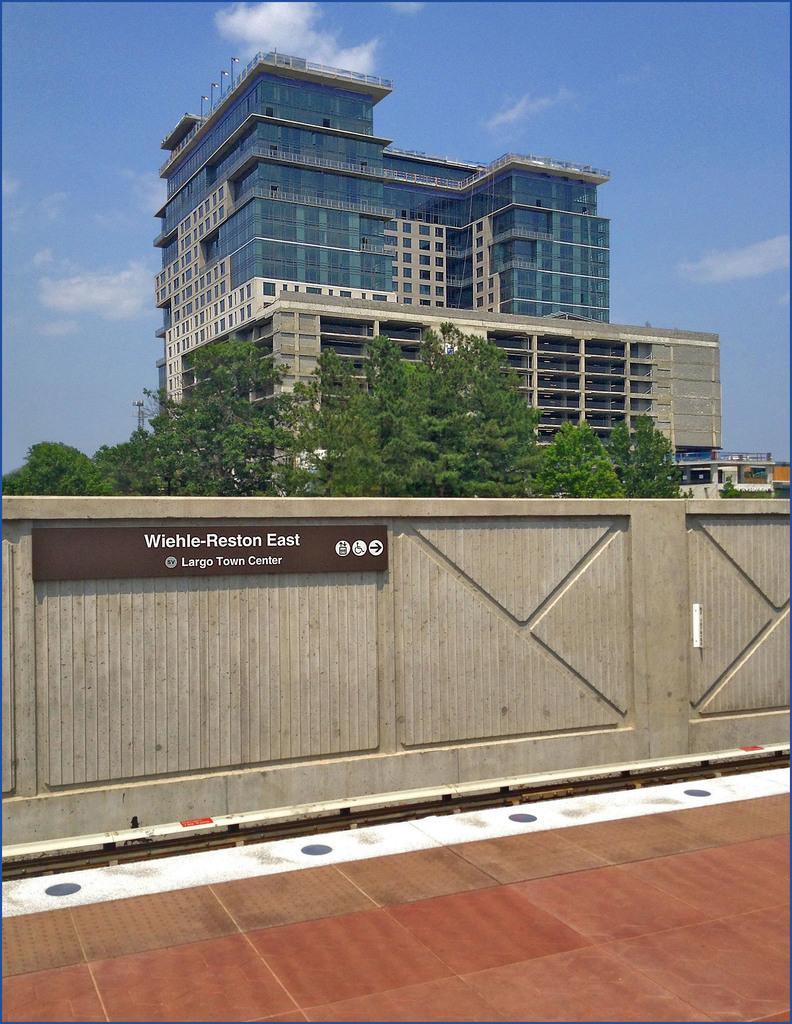In one or two sentences, can you explain what this image depicts? In this picture we can see the ground, trees, building, name board on the wall and in the background we can see the sky with clouds. 